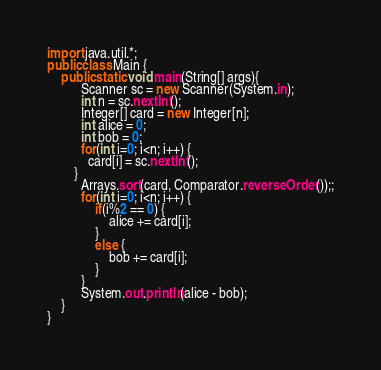Convert code to text. <code><loc_0><loc_0><loc_500><loc_500><_Java_>import java.util.*;
public class Main {
	public static void main(String[] args){
	      Scanner sc = new Scanner(System.in);
	      int n = sc.nextInt();
	      Integer[] card = new Integer[n];
	      int alice = 0;
	      int bob = 0;
	      for(int i=0; i<n; i++) {
	  		card[i] = sc.nextInt();
	  	}
	      Arrays.sort(card, Comparator.reverseOrder());;
	      for(int i=0; i<n; i++) {
	    	  if(i%2 == 0) {
	    		  alice += card[i];
	    	  }
	    	  else {
	    		  bob += card[i];
	    	  }
	      }
	      System.out.println(alice - bob);
	}
}</code> 